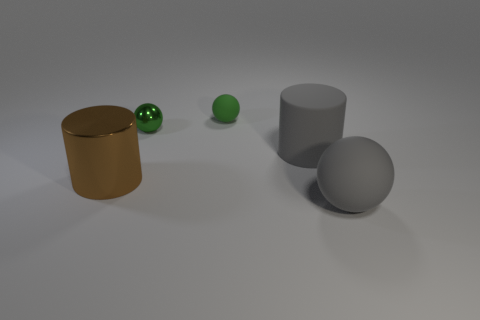There is a big gray rubber thing behind the big brown cylinder; is its shape the same as the small object on the right side of the metallic ball?
Offer a terse response. No. The large gray matte object that is behind the brown cylinder that is to the left of the small green matte thing is what shape?
Your response must be concise. Cylinder. What size is the object that is the same color as the large matte cylinder?
Keep it short and to the point. Large. Is there a small cyan cube that has the same material as the gray cylinder?
Your response must be concise. No. What is the material of the ball in front of the large matte cylinder?
Your answer should be compact. Rubber. What material is the big ball?
Give a very brief answer. Rubber. Is the small green thing behind the tiny metallic sphere made of the same material as the large gray sphere?
Keep it short and to the point. Yes. Are there fewer large spheres right of the big gray sphere than small green metallic balls?
Provide a succinct answer. Yes. There is another cylinder that is the same size as the brown shiny cylinder; what color is it?
Your answer should be very brief. Gray. What number of other large metallic objects have the same shape as the large brown metallic thing?
Provide a succinct answer. 0. 